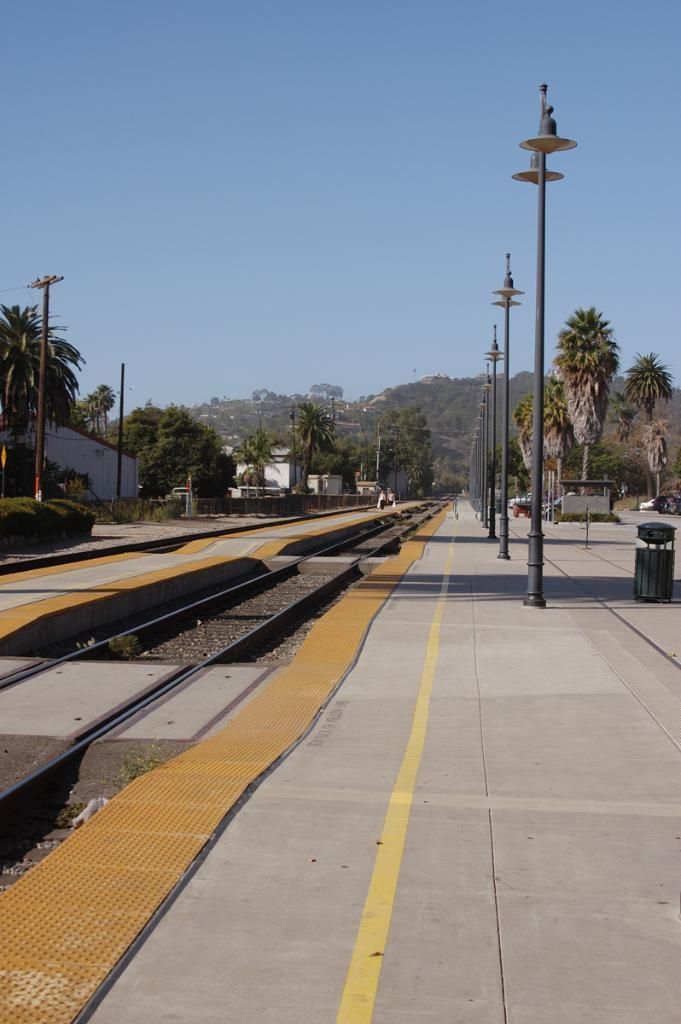What structures can be seen in the image? There are poles and lights in the image. What type of natural elements are present in the image? There are trees in the image. What man-made structures are related to transportation in the image? Railway tracks and a platform are present in the image. What is visible in the sky in the image? The sky is visible in the image. What can be observed due to the presence of light and objects in the image? Shadows are present in the image. What object is present for waste disposal in the image? There is a dustbin in the image. Can you tell me how many giraffes are playing on the platform in the image? There are no giraffes present in the image, and they cannot play on the platform as they are not in the image. What time of day is it in the image? The time of day cannot be determined from the image alone, as there is no specific information about the time provided. 